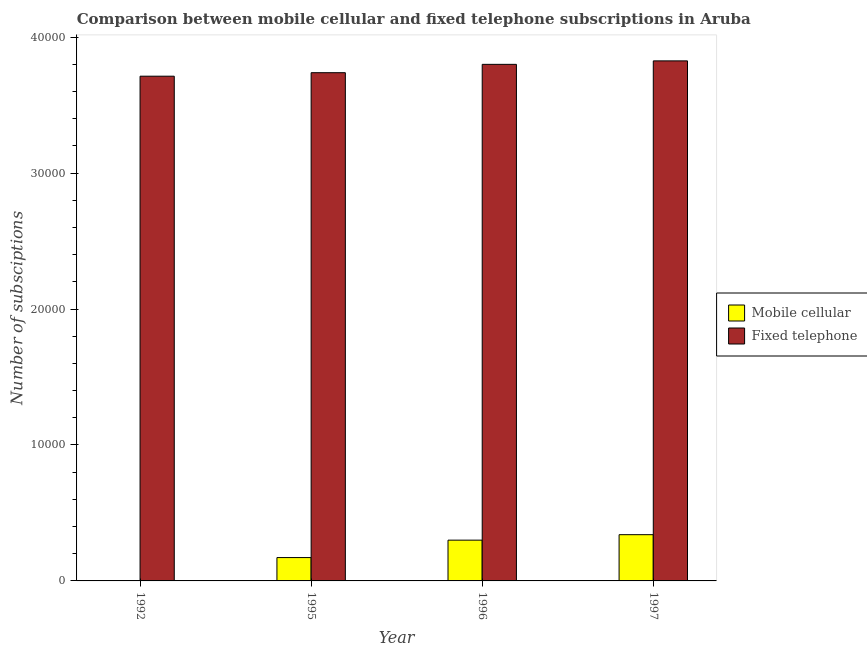How many different coloured bars are there?
Make the answer very short. 2. Are the number of bars on each tick of the X-axis equal?
Offer a terse response. Yes. How many bars are there on the 2nd tick from the right?
Give a very brief answer. 2. What is the label of the 1st group of bars from the left?
Make the answer very short. 1992. In how many cases, is the number of bars for a given year not equal to the number of legend labels?
Keep it short and to the point. 0. What is the number of fixed telephone subscriptions in 1997?
Your answer should be very brief. 3.83e+04. Across all years, what is the maximum number of fixed telephone subscriptions?
Your answer should be very brief. 3.83e+04. Across all years, what is the minimum number of mobile cellular subscriptions?
Your answer should be very brief. 20. What is the total number of fixed telephone subscriptions in the graph?
Make the answer very short. 1.51e+05. What is the difference between the number of mobile cellular subscriptions in 1995 and that in 1997?
Your response must be concise. -1684. What is the difference between the number of fixed telephone subscriptions in 1996 and the number of mobile cellular subscriptions in 1995?
Your answer should be very brief. 613. What is the average number of fixed telephone subscriptions per year?
Your answer should be compact. 3.77e+04. In how many years, is the number of mobile cellular subscriptions greater than 14000?
Make the answer very short. 0. What is the ratio of the number of mobile cellular subscriptions in 1995 to that in 1996?
Offer a terse response. 0.57. Is the number of fixed telephone subscriptions in 1995 less than that in 1996?
Provide a short and direct response. Yes. What is the difference between the highest and the second highest number of fixed telephone subscriptions?
Offer a terse response. 256. What is the difference between the highest and the lowest number of fixed telephone subscriptions?
Your answer should be compact. 1127. Is the sum of the number of fixed telephone subscriptions in 1995 and 1996 greater than the maximum number of mobile cellular subscriptions across all years?
Provide a short and direct response. Yes. What does the 1st bar from the left in 1997 represents?
Your answer should be compact. Mobile cellular. What does the 1st bar from the right in 1996 represents?
Ensure brevity in your answer.  Fixed telephone. Are all the bars in the graph horizontal?
Offer a terse response. No. How many years are there in the graph?
Make the answer very short. 4. What is the difference between two consecutive major ticks on the Y-axis?
Your answer should be compact. 10000. Are the values on the major ticks of Y-axis written in scientific E-notation?
Provide a succinct answer. No. What is the title of the graph?
Provide a short and direct response. Comparison between mobile cellular and fixed telephone subscriptions in Aruba. Does "Primary education" appear as one of the legend labels in the graph?
Provide a succinct answer. No. What is the label or title of the Y-axis?
Your answer should be compact. Number of subsciptions. What is the Number of subsciptions in Mobile cellular in 1992?
Provide a short and direct response. 20. What is the Number of subsciptions in Fixed telephone in 1992?
Offer a very short reply. 3.71e+04. What is the Number of subsciptions of Mobile cellular in 1995?
Offer a terse response. 1718. What is the Number of subsciptions of Fixed telephone in 1995?
Your answer should be very brief. 3.74e+04. What is the Number of subsciptions of Mobile cellular in 1996?
Give a very brief answer. 3000. What is the Number of subsciptions in Fixed telephone in 1996?
Your response must be concise. 3.80e+04. What is the Number of subsciptions of Mobile cellular in 1997?
Your answer should be very brief. 3402. What is the Number of subsciptions of Fixed telephone in 1997?
Your response must be concise. 3.83e+04. Across all years, what is the maximum Number of subsciptions in Mobile cellular?
Provide a short and direct response. 3402. Across all years, what is the maximum Number of subsciptions of Fixed telephone?
Your answer should be very brief. 3.83e+04. Across all years, what is the minimum Number of subsciptions in Mobile cellular?
Offer a very short reply. 20. Across all years, what is the minimum Number of subsciptions in Fixed telephone?
Make the answer very short. 3.71e+04. What is the total Number of subsciptions of Mobile cellular in the graph?
Give a very brief answer. 8140. What is the total Number of subsciptions in Fixed telephone in the graph?
Provide a succinct answer. 1.51e+05. What is the difference between the Number of subsciptions of Mobile cellular in 1992 and that in 1995?
Give a very brief answer. -1698. What is the difference between the Number of subsciptions of Fixed telephone in 1992 and that in 1995?
Provide a short and direct response. -258. What is the difference between the Number of subsciptions of Mobile cellular in 1992 and that in 1996?
Ensure brevity in your answer.  -2980. What is the difference between the Number of subsciptions in Fixed telephone in 1992 and that in 1996?
Provide a succinct answer. -871. What is the difference between the Number of subsciptions of Mobile cellular in 1992 and that in 1997?
Make the answer very short. -3382. What is the difference between the Number of subsciptions in Fixed telephone in 1992 and that in 1997?
Give a very brief answer. -1127. What is the difference between the Number of subsciptions of Mobile cellular in 1995 and that in 1996?
Give a very brief answer. -1282. What is the difference between the Number of subsciptions of Fixed telephone in 1995 and that in 1996?
Give a very brief answer. -613. What is the difference between the Number of subsciptions of Mobile cellular in 1995 and that in 1997?
Offer a very short reply. -1684. What is the difference between the Number of subsciptions of Fixed telephone in 1995 and that in 1997?
Provide a short and direct response. -869. What is the difference between the Number of subsciptions in Mobile cellular in 1996 and that in 1997?
Your answer should be very brief. -402. What is the difference between the Number of subsciptions in Fixed telephone in 1996 and that in 1997?
Make the answer very short. -256. What is the difference between the Number of subsciptions of Mobile cellular in 1992 and the Number of subsciptions of Fixed telephone in 1995?
Make the answer very short. -3.74e+04. What is the difference between the Number of subsciptions of Mobile cellular in 1992 and the Number of subsciptions of Fixed telephone in 1996?
Offer a very short reply. -3.80e+04. What is the difference between the Number of subsciptions in Mobile cellular in 1992 and the Number of subsciptions in Fixed telephone in 1997?
Your response must be concise. -3.82e+04. What is the difference between the Number of subsciptions of Mobile cellular in 1995 and the Number of subsciptions of Fixed telephone in 1996?
Offer a very short reply. -3.63e+04. What is the difference between the Number of subsciptions of Mobile cellular in 1995 and the Number of subsciptions of Fixed telephone in 1997?
Offer a very short reply. -3.65e+04. What is the difference between the Number of subsciptions in Mobile cellular in 1996 and the Number of subsciptions in Fixed telephone in 1997?
Your response must be concise. -3.53e+04. What is the average Number of subsciptions in Mobile cellular per year?
Make the answer very short. 2035. What is the average Number of subsciptions in Fixed telephone per year?
Provide a succinct answer. 3.77e+04. In the year 1992, what is the difference between the Number of subsciptions in Mobile cellular and Number of subsciptions in Fixed telephone?
Offer a terse response. -3.71e+04. In the year 1995, what is the difference between the Number of subsciptions of Mobile cellular and Number of subsciptions of Fixed telephone?
Offer a very short reply. -3.57e+04. In the year 1996, what is the difference between the Number of subsciptions in Mobile cellular and Number of subsciptions in Fixed telephone?
Your answer should be very brief. -3.50e+04. In the year 1997, what is the difference between the Number of subsciptions in Mobile cellular and Number of subsciptions in Fixed telephone?
Your answer should be compact. -3.49e+04. What is the ratio of the Number of subsciptions of Mobile cellular in 1992 to that in 1995?
Offer a very short reply. 0.01. What is the ratio of the Number of subsciptions of Fixed telephone in 1992 to that in 1995?
Ensure brevity in your answer.  0.99. What is the ratio of the Number of subsciptions of Mobile cellular in 1992 to that in 1996?
Provide a succinct answer. 0.01. What is the ratio of the Number of subsciptions of Fixed telephone in 1992 to that in 1996?
Keep it short and to the point. 0.98. What is the ratio of the Number of subsciptions in Mobile cellular in 1992 to that in 1997?
Give a very brief answer. 0.01. What is the ratio of the Number of subsciptions in Fixed telephone in 1992 to that in 1997?
Offer a very short reply. 0.97. What is the ratio of the Number of subsciptions of Mobile cellular in 1995 to that in 1996?
Ensure brevity in your answer.  0.57. What is the ratio of the Number of subsciptions of Fixed telephone in 1995 to that in 1996?
Your answer should be very brief. 0.98. What is the ratio of the Number of subsciptions in Mobile cellular in 1995 to that in 1997?
Offer a terse response. 0.51. What is the ratio of the Number of subsciptions in Fixed telephone in 1995 to that in 1997?
Ensure brevity in your answer.  0.98. What is the ratio of the Number of subsciptions of Mobile cellular in 1996 to that in 1997?
Offer a terse response. 0.88. What is the ratio of the Number of subsciptions of Fixed telephone in 1996 to that in 1997?
Offer a terse response. 0.99. What is the difference between the highest and the second highest Number of subsciptions of Mobile cellular?
Provide a short and direct response. 402. What is the difference between the highest and the second highest Number of subsciptions in Fixed telephone?
Your response must be concise. 256. What is the difference between the highest and the lowest Number of subsciptions of Mobile cellular?
Provide a short and direct response. 3382. What is the difference between the highest and the lowest Number of subsciptions of Fixed telephone?
Keep it short and to the point. 1127. 